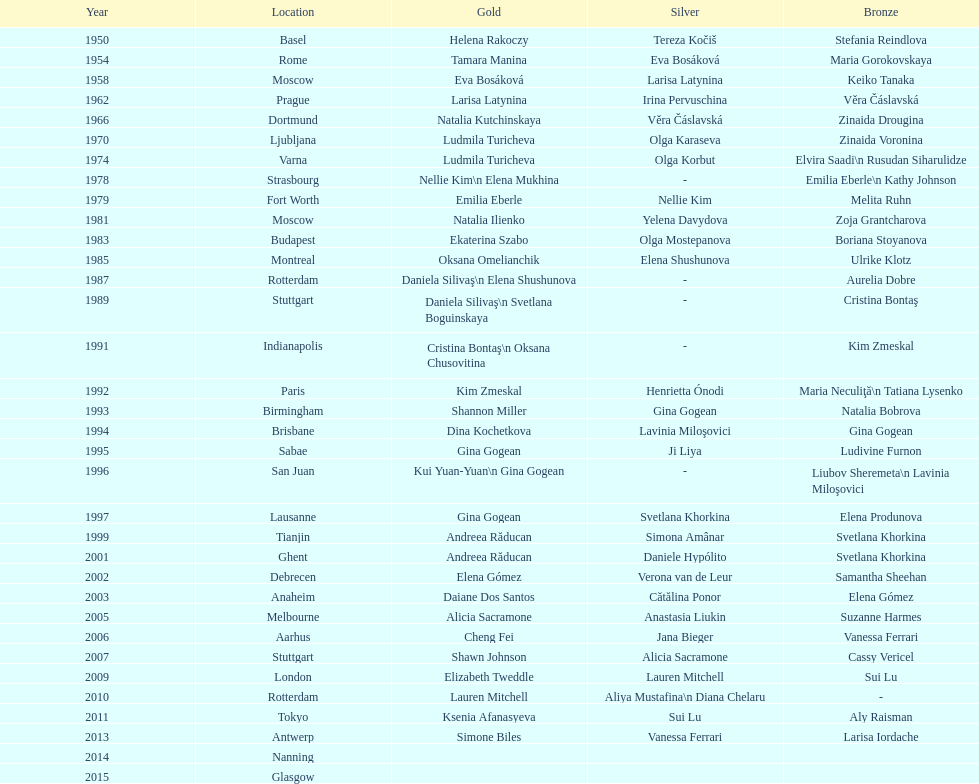How often was the place situated in the united states? 3. 